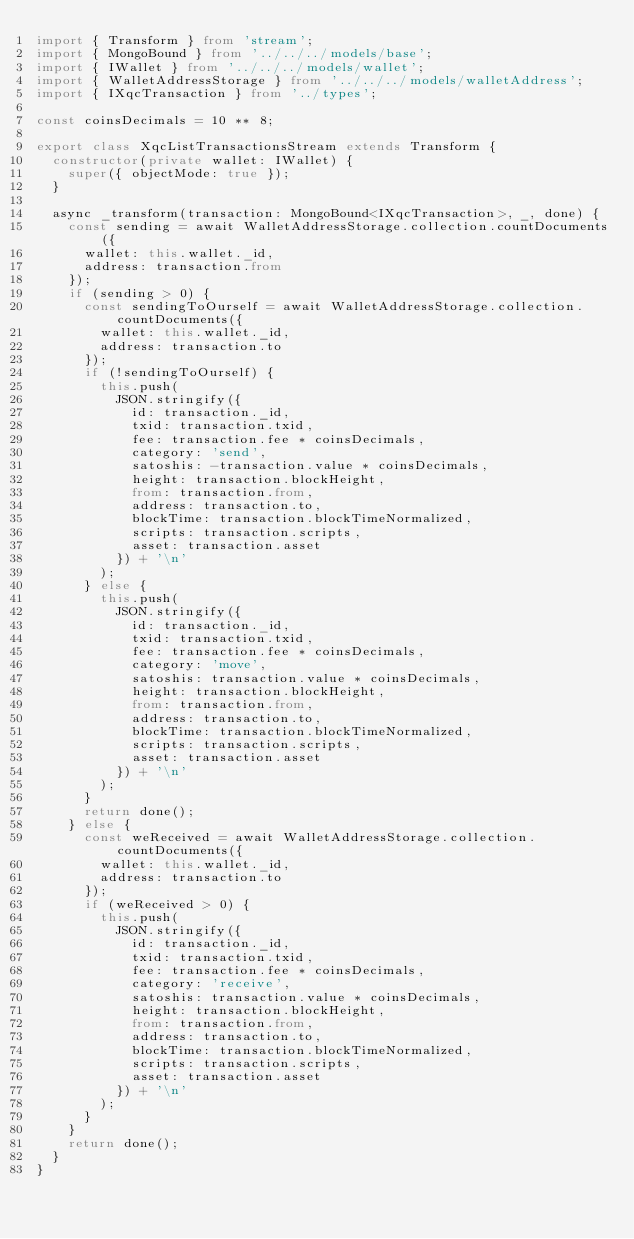Convert code to text. <code><loc_0><loc_0><loc_500><loc_500><_TypeScript_>import { Transform } from 'stream';
import { MongoBound } from '../../../models/base';
import { IWallet } from '../../../models/wallet';
import { WalletAddressStorage } from '../../../models/walletAddress';
import { IXqcTransaction } from '../types';

const coinsDecimals = 10 ** 8;

export class XqcListTransactionsStream extends Transform {
  constructor(private wallet: IWallet) {
    super({ objectMode: true });
  }

  async _transform(transaction: MongoBound<IXqcTransaction>, _, done) {
    const sending = await WalletAddressStorage.collection.countDocuments({
      wallet: this.wallet._id,
      address: transaction.from
    });
    if (sending > 0) {
      const sendingToOurself = await WalletAddressStorage.collection.countDocuments({
        wallet: this.wallet._id,
        address: transaction.to
      });
      if (!sendingToOurself) {
        this.push(
          JSON.stringify({
            id: transaction._id,
            txid: transaction.txid,
            fee: transaction.fee * coinsDecimals,
            category: 'send',
            satoshis: -transaction.value * coinsDecimals,
            height: transaction.blockHeight,
            from: transaction.from,
            address: transaction.to,
            blockTime: transaction.blockTimeNormalized,
            scripts: transaction.scripts,
            asset: transaction.asset
          }) + '\n'
        );
      } else {
        this.push(
          JSON.stringify({
            id: transaction._id,
            txid: transaction.txid,
            fee: transaction.fee * coinsDecimals,
            category: 'move',
            satoshis: transaction.value * coinsDecimals,
            height: transaction.blockHeight,
            from: transaction.from,
            address: transaction.to,
            blockTime: transaction.blockTimeNormalized,
            scripts: transaction.scripts,
            asset: transaction.asset
          }) + '\n'
        );
      }
      return done();
    } else {
      const weReceived = await WalletAddressStorage.collection.countDocuments({
        wallet: this.wallet._id,
        address: transaction.to
      });
      if (weReceived > 0) {
        this.push(
          JSON.stringify({
            id: transaction._id,
            txid: transaction.txid,
            fee: transaction.fee * coinsDecimals,
            category: 'receive',
            satoshis: transaction.value * coinsDecimals,
            height: transaction.blockHeight,
            from: transaction.from,
            address: transaction.to,
            blockTime: transaction.blockTimeNormalized,
            scripts: transaction.scripts,
            asset: transaction.asset
          }) + '\n'
        );
      }
    }
    return done();
  }
}
</code> 